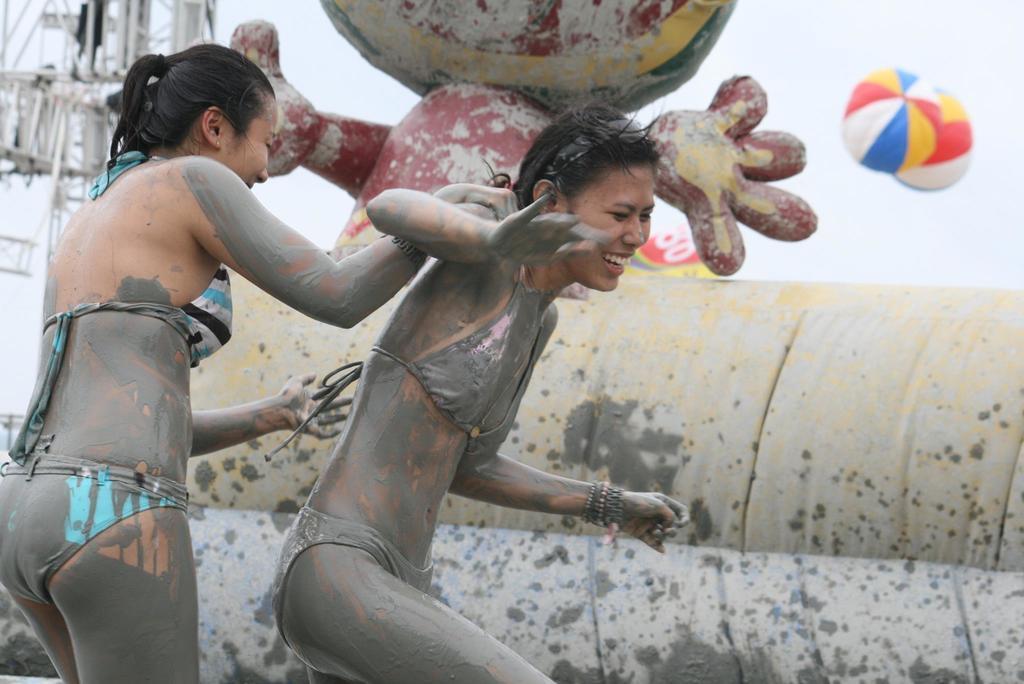In one or two sentences, can you explain what this image depicts? In the image there are two ladies. Behind them there is a wall. Behind the wall there is a statue. And also there is tower. In the background there are parachutes. 